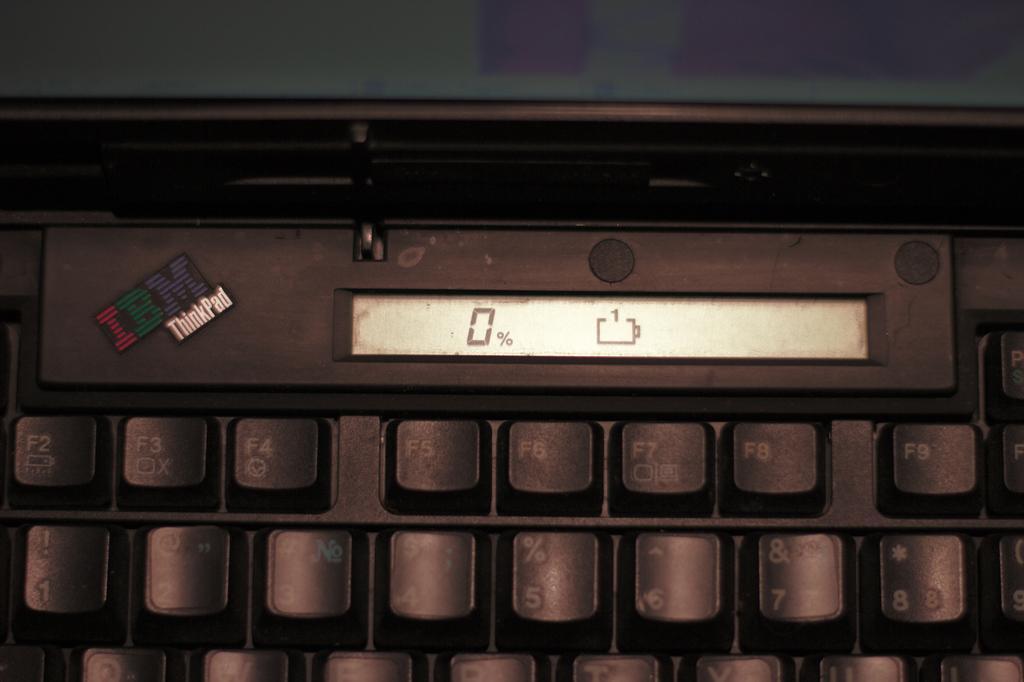Could you give a brief overview of what you see in this image? In this image there is a keyboard. 